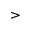<formula> <loc_0><loc_0><loc_500><loc_500>></formula> 